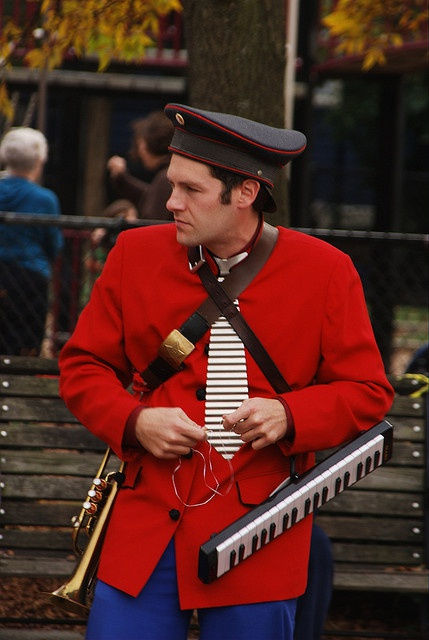Describe the objects in this image and their specific colors. I can see people in maroon, brown, black, and navy tones, bench in maroon, black, and gray tones, people in maroon, black, navy, blue, and gray tones, tie in maroon, lightgray, darkgray, and gray tones, and people in maroon, black, and brown tones in this image. 